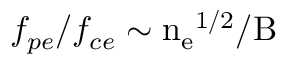<formula> <loc_0><loc_0><loc_500><loc_500>f _ { p e } / f _ { c e } \sim n _ { e } ^ { 1 / 2 } / B</formula> 